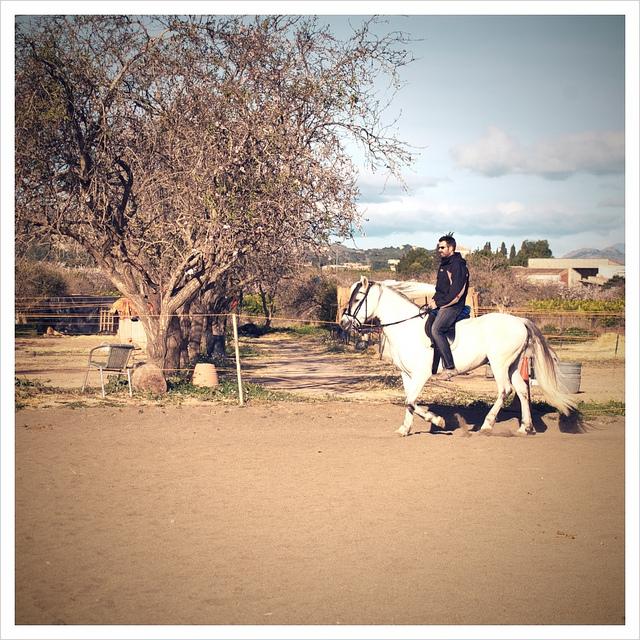Is the man wearing sunglasses?
Give a very brief answer. Yes. What is the weather like?
Concise answer only. Sunny. What is the man riding around the arena?
Give a very brief answer. Horse. How many horses in the photo?
Give a very brief answer. 1. 